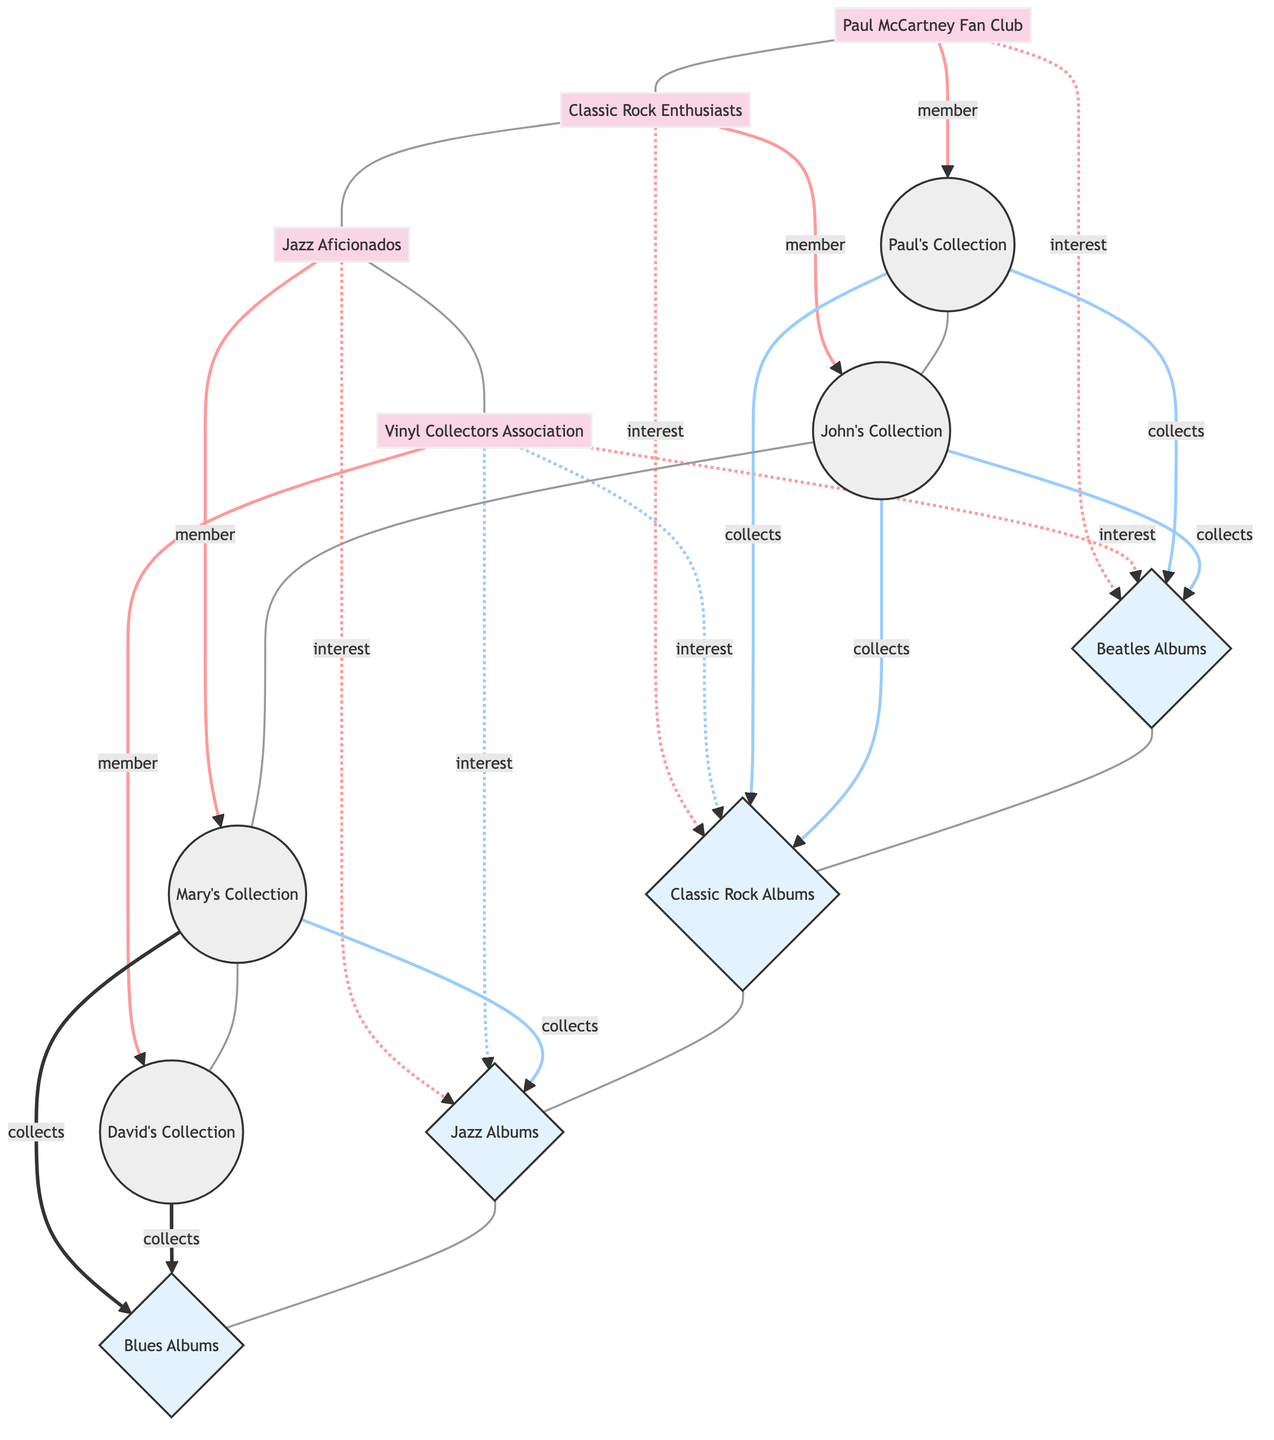What is the total number of nodes in the diagram? The total number of nodes is found by counting all individual collectors, collector groups, and genres listed in the nodes section. There are 8 individual collectors, 4 collector groups, and 4 genres, resulting in a total of 16 nodes.
Answer: 16 How many members are in the "Vinyl Collectors Association"? To find the number of members, we look at the relationship between the "Vinyl Collectors Association" node and the individual collectors. It shows that David's Collection is the only member linked to this group.
Answer: 1 Which genre is Paul McCartney's Collection primarily associated with? We examine the relationships of "Paul's Collection" node. It has direct "collects" relationships with the "Beatles Albums" and "Classic Rock Albums" genres. Either genre can be considered primary since both have direct relationships.
Answer: Beatles Albums What relationship exists between "John's Collection" and "Classic Rock Albums"? Looking at the connections to "John's Collection," we see that it is linked with "Classic Rock Albums" through a "collects" relationship. This direct link signifies that John's Collection actively includes albums from this genre.
Answer: collects How many individual collectors collect Jazz Albums? To determine the number of individual collectors that collect "Jazz Albums," we trace the connections from the "Jazz Albums" node. Mary’s Collection shows a "collects" relationship with "Jazz Albums," meaning only 1 individual collector is associated with this genre in this specific diagram.
Answer: 1 Which collector group shows interest in Blues Albums? Analyzing the diagram, we note that "Blues Albums" has no direct interest relationships with any collector groups. Thus, there are no collector groups interested in this genre shown in the diagram.
Answer: None How many collector groups are linked to the Beatles Albums? To find the count of collector groups linked to "Beatles Albums," review the individual relationships. The "Paul McCartney Fan Club" and "Vinyl Collectors Association" both have an "interest" relationship with "Beatles Albums." Thus, there are 2 collector groups linked to this genre.
Answer: 2 Which individual collector belongs to the "Classic Rock Enthusiasts"? The "Classic Rock Enthusiasts" collector group is linked to "John's Collection" as a member. Therefore, John's Collection is the individual collector that belongs to this group.
Answer: John's Collection What is the total number of relationships shown in the diagram? By counting each connection (link) described between nodes in the "links" section, we can sum them up. In this diagram, there are a total of 14 relationships connecting groups and individuals to genres.
Answer: 14 